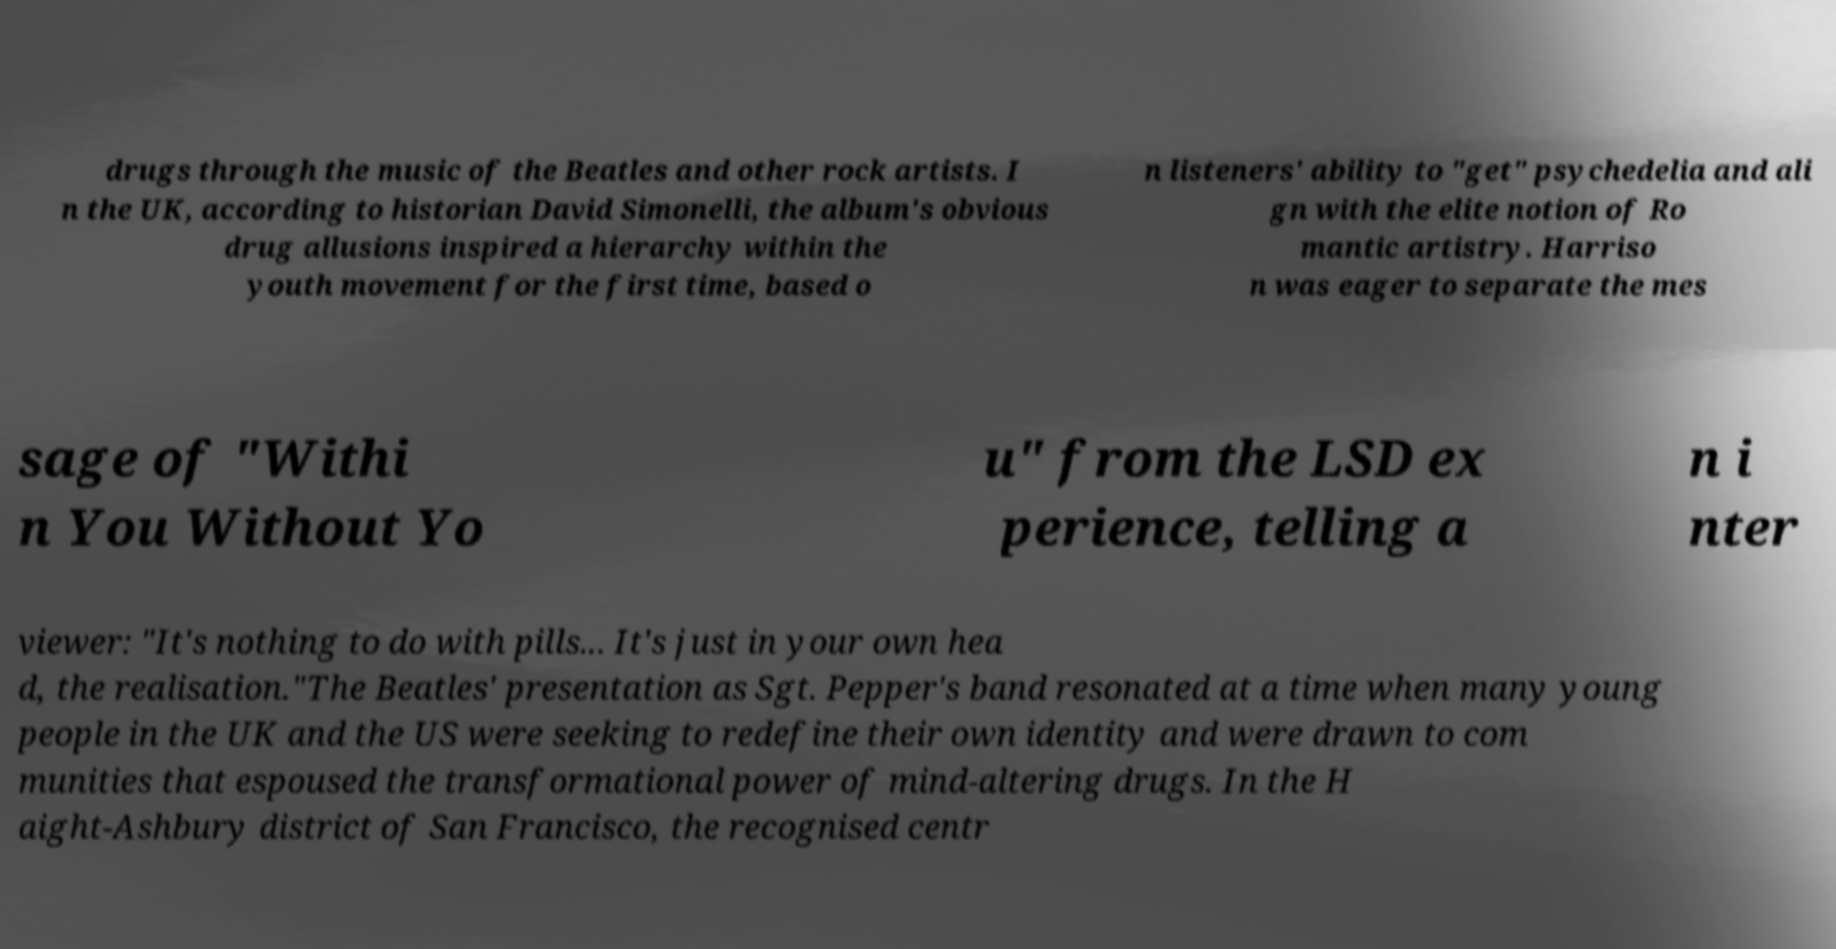For documentation purposes, I need the text within this image transcribed. Could you provide that? drugs through the music of the Beatles and other rock artists. I n the UK, according to historian David Simonelli, the album's obvious drug allusions inspired a hierarchy within the youth movement for the first time, based o n listeners' ability to "get" psychedelia and ali gn with the elite notion of Ro mantic artistry. Harriso n was eager to separate the mes sage of "Withi n You Without Yo u" from the LSD ex perience, telling a n i nter viewer: "It's nothing to do with pills... It's just in your own hea d, the realisation."The Beatles' presentation as Sgt. Pepper's band resonated at a time when many young people in the UK and the US were seeking to redefine their own identity and were drawn to com munities that espoused the transformational power of mind-altering drugs. In the H aight-Ashbury district of San Francisco, the recognised centr 